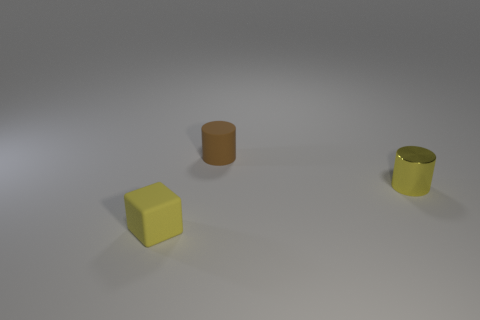The tiny rubber thing that is the same color as the shiny cylinder is what shape?
Your answer should be compact. Cube. Is there any other thing that is made of the same material as the yellow cylinder?
Provide a succinct answer. No. Do the tiny metallic thing and the matte cube have the same color?
Make the answer very short. Yes. How many tiny objects are in front of the tiny brown object and right of the yellow block?
Give a very brief answer. 1. How many small rubber cylinders are behind the rubber object in front of the matte object that is behind the small yellow block?
Your response must be concise. 1. What shape is the small yellow metal thing?
Your answer should be compact. Cylinder. What number of other tiny cylinders have the same material as the yellow cylinder?
Ensure brevity in your answer.  0. The block that is made of the same material as the small brown thing is what color?
Offer a terse response. Yellow. What material is the yellow object that is left of the small rubber object that is behind the rubber object in front of the tiny brown rubber object?
Your response must be concise. Rubber. What number of things are either small yellow matte cubes or shiny objects?
Ensure brevity in your answer.  2. 